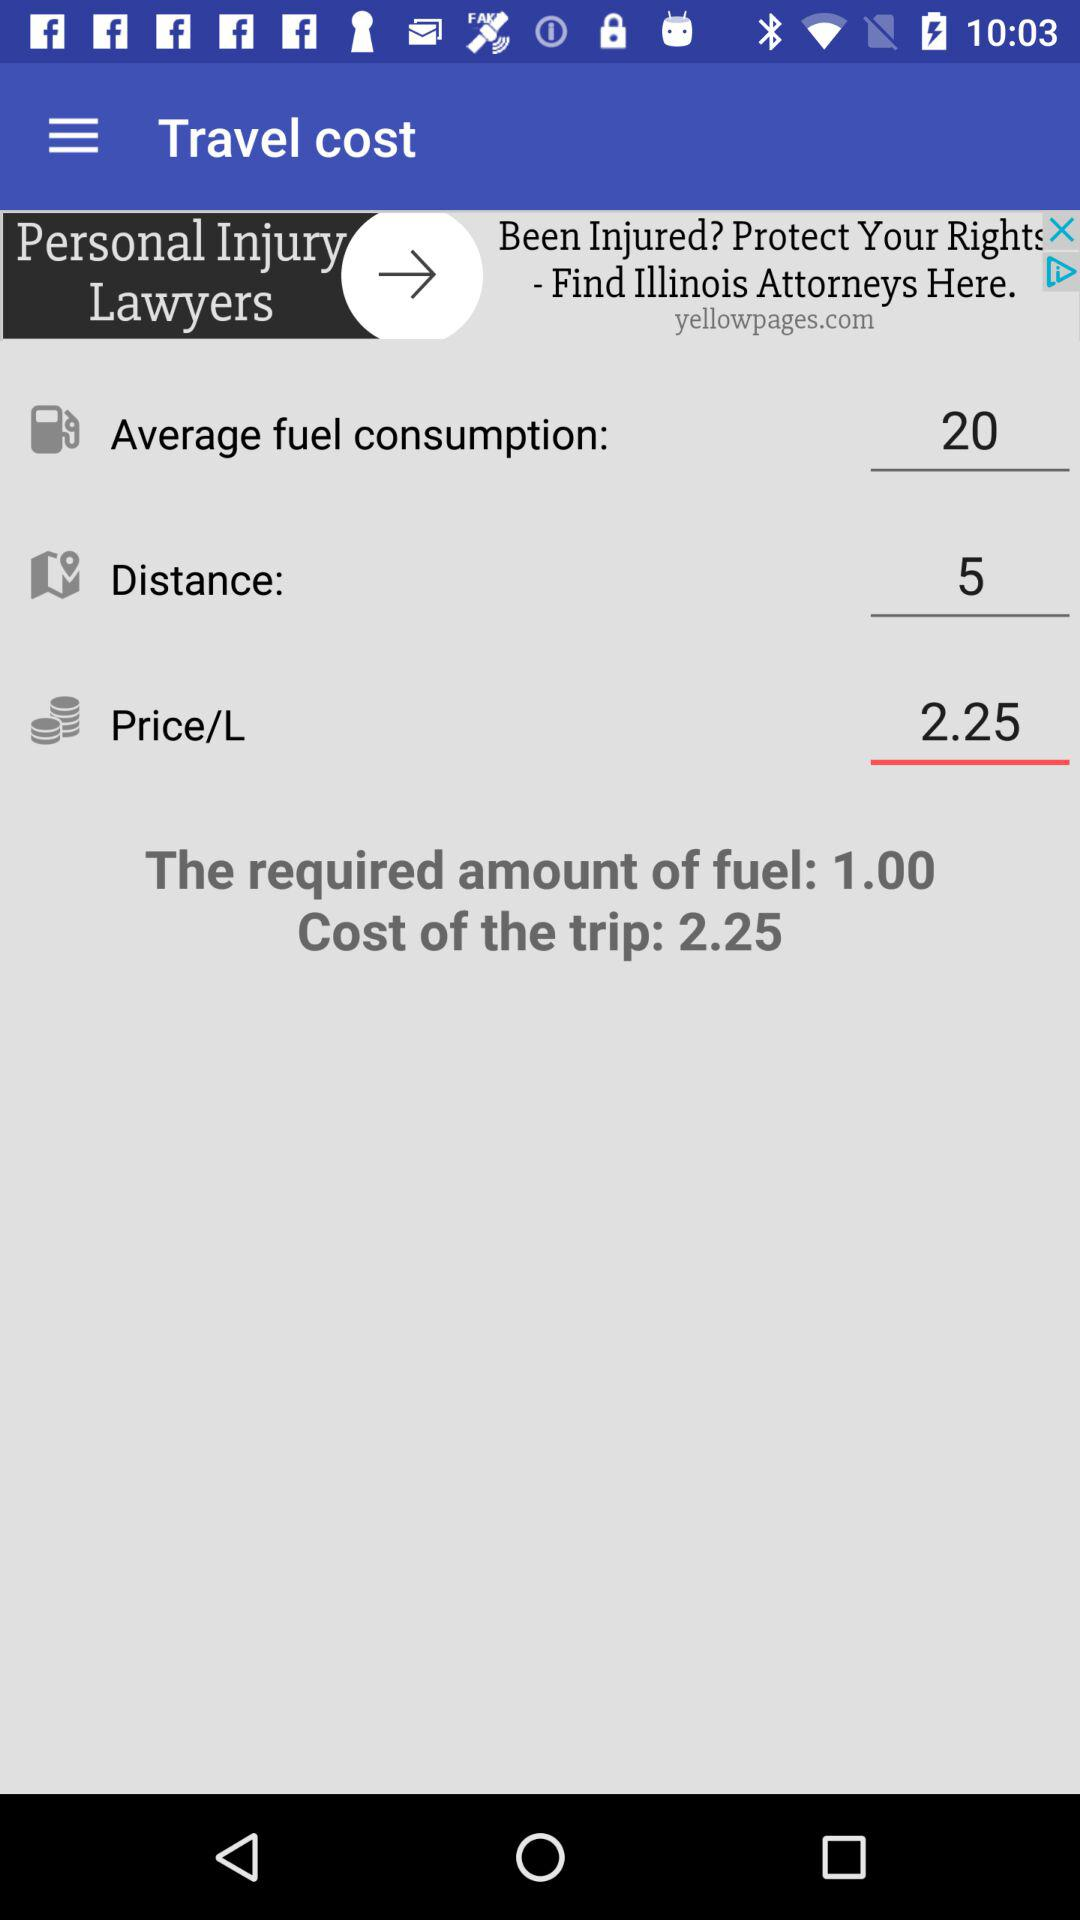What is the average fuel consumption? The average fuel consumption is 20. 